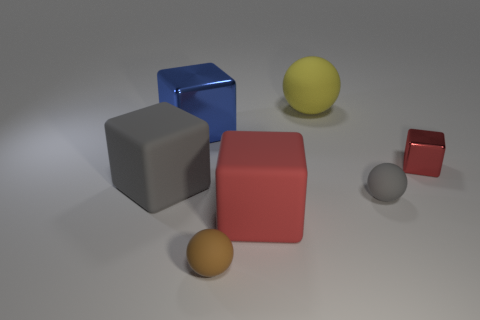How many balls are small red things or matte objects? In the image, there is one small red ball and two matte objects. So according to your question, there are three items in total that are either small red balls or matte objects. 